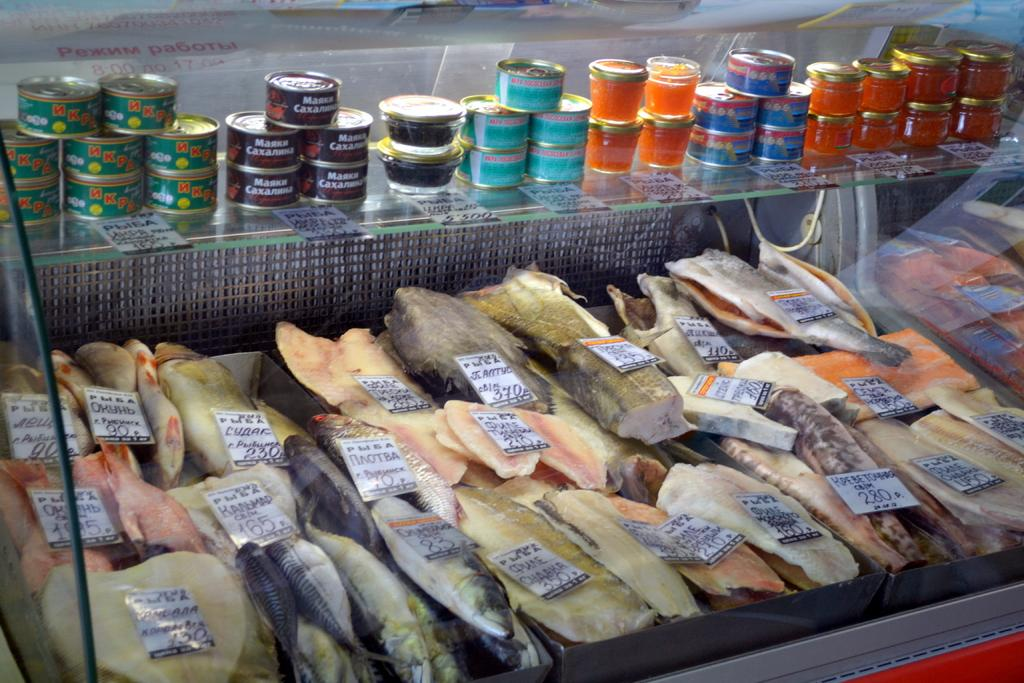What types of food can be seen on the trays in the image? There are fish and meat on the trays in the image. What else is present on the trays besides food? There are cards on the trays in the image. What can be seen at the top of the image? There are containers visible at the top of the image. Where are more cards located in the image? There are cards on a glass rack in the image. What else is present in the image besides the trays and cards? Wires are present in the image, and there is a glass object in the image. Can you see any clouds in the image? No, there are no clouds present in the image. Is there a snail visible on the trays in the image? No, there is no snail present in the image. 